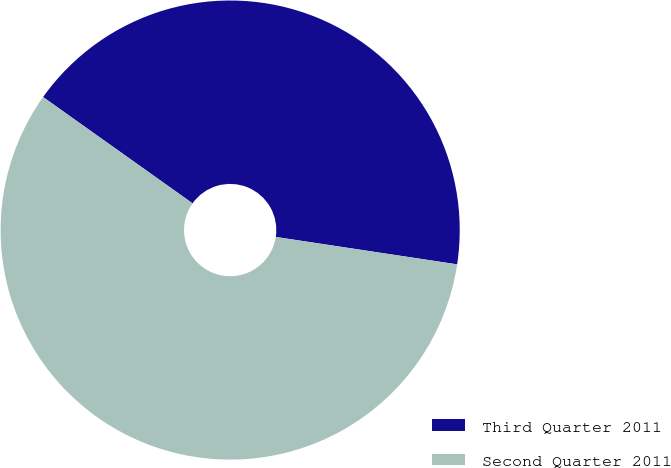Convert chart. <chart><loc_0><loc_0><loc_500><loc_500><pie_chart><fcel>Third Quarter 2011<fcel>Second Quarter 2011<nl><fcel>42.55%<fcel>57.45%<nl></chart> 